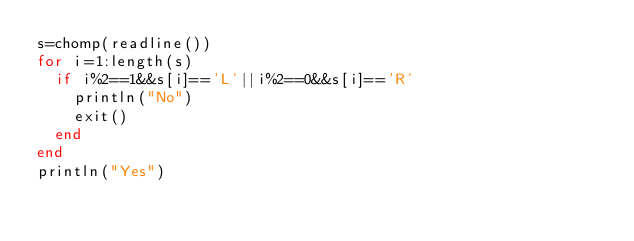<code> <loc_0><loc_0><loc_500><loc_500><_Julia_>s=chomp(readline())
for i=1:length(s)
  if i%2==1&&s[i]=='L'||i%2==0&&s[i]=='R'
    println("No")
    exit()
  end
end
println("Yes")</code> 